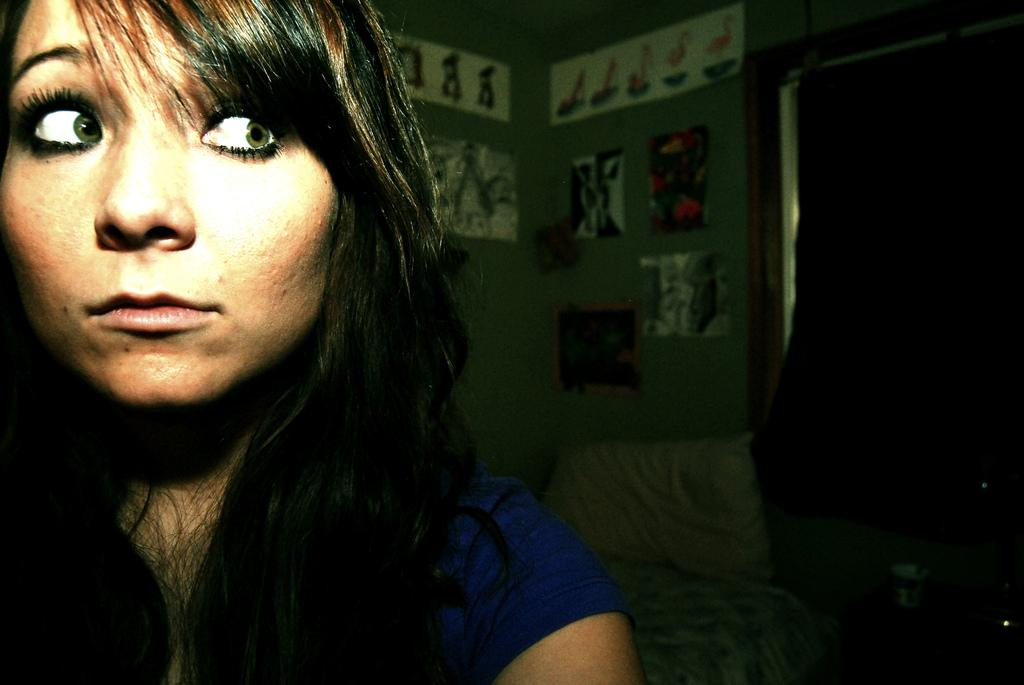Who is the main subject in the image? There is a girl in the image. What is the girl wearing? The girl is wearing clothes. What can be seen on the wall in the image? There are frame(s) on the wall in the image. How many pages are visible in the image? There are no pages present in the image. What type of elbow can be seen in the image? There is no elbow visible in the image. 